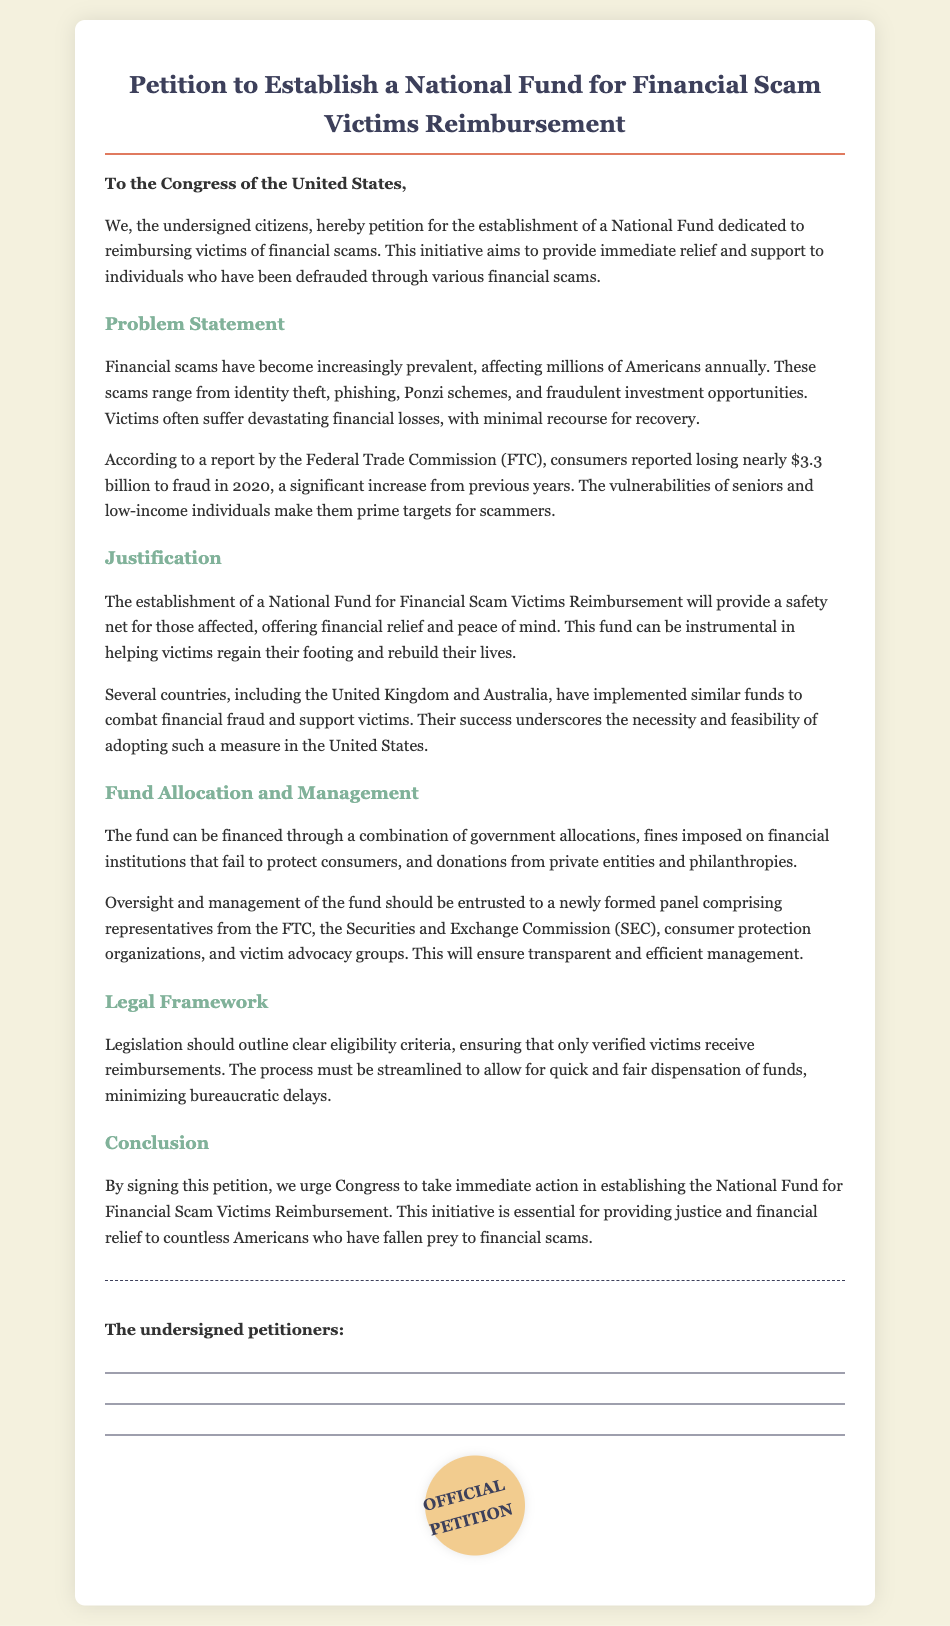What is the title of the petition? The title of the petition is prominently displayed at the top of the document.
Answer: Petition to Establish a National Fund for Financial Scam Victims Reimbursement Who is the intended recipient of the petition? The document addresses a specific group, indicated at the beginning of the text.
Answer: Congress of the United States What was the reported loss to fraud in 2020? The document states a specific monetary amount reported by the FTC regarding financial fraud losses.
Answer: Nearly $3.3 billion Which types of scams are mentioned? The document lists various forms of scams that victims may experience.
Answer: Identity theft, phishing, Ponzi schemes, fraudulent investment opportunities What should manage the fund according to the petition? The petition outlines a specific group responsible for overseeing the fund’s management.
Answer: A newly formed panel Which countries have implemented similar funds? The document references external countries that have enacted similar financial victim support measures.
Answer: United Kingdom and Australia What does the petition urge Congress to take action on? The conclusion of the document emphasizes a particular request for Congress's action.
Answer: Establishing the National Fund for Financial Scam Victims Reimbursement 